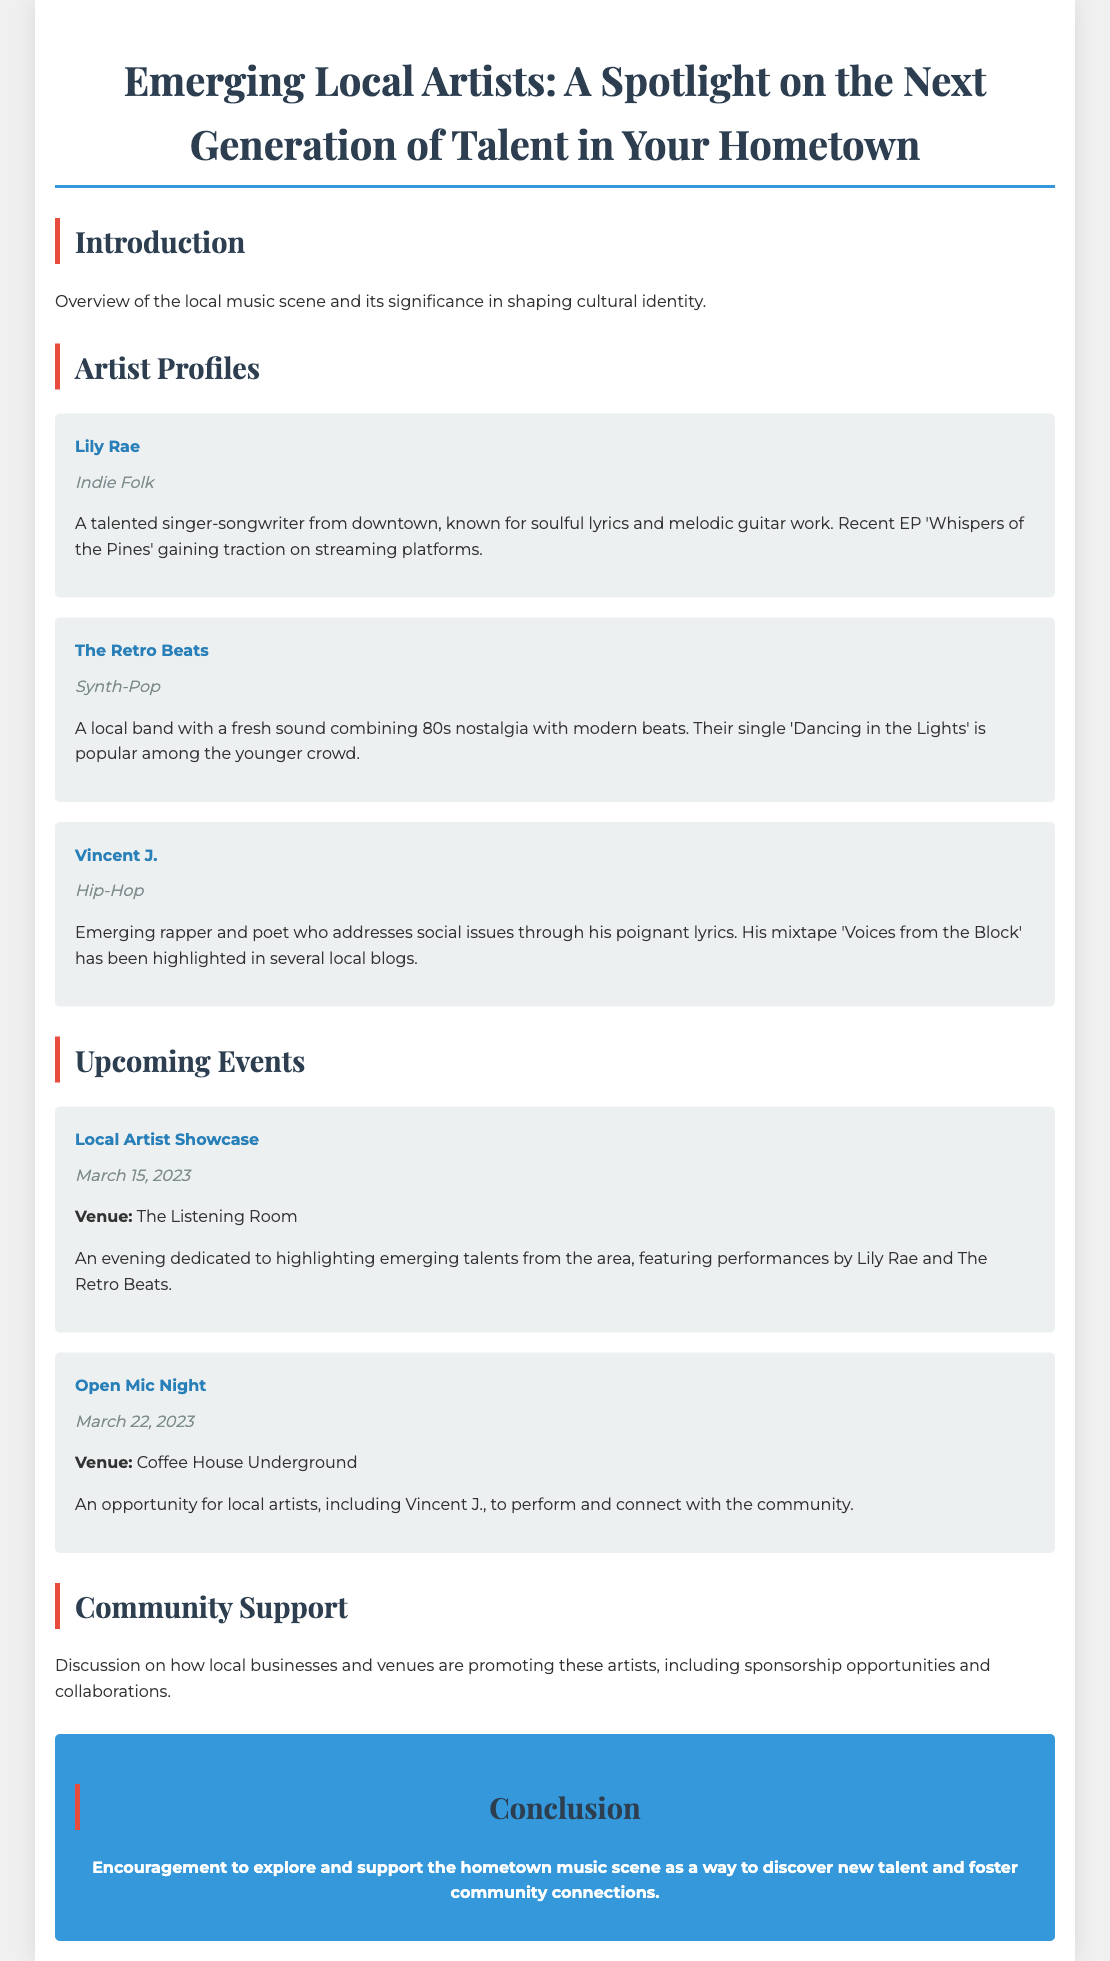What is the title of the document? The title is stated at the beginning of the document and encapsulates the focus on local artists.
Answer: Emerging Local Artists: A Spotlight on the Next Generation of Talent in Your Hometown Who is the first artist profiled? The first artist mentioned in the 'Artist Profiles' section is identified by name.
Answer: Lily Rae What genre does Vincent J. represent? The genre associated with Vincent J. is listed in his profile.
Answer: Hip-Hop When is the Local Artist Showcase event scheduled? The date for the Local Artist Showcase is presented under the 'Upcoming Events' section.
Answer: March 15, 2023 What is the name of the venue for the Open Mic Night? The venue for the Open Mic Night is specifically mentioned in the event details.
Answer: Coffee House Underground What is the focus of the community support section? The section discusses how local businesses engage with artists, indicating its purpose.
Answer: Promotion of local artists Which artist is described as having a popular single among the younger crowd? The document specifically notes which artist has a single appealing to a particular demographic.
Answer: The Retro Beats What is the title of Lily Rae's recent EP? The title is cited as part of her profile, reflecting her recent work.
Answer: Whispers of the Pines What type of music does The Retro Beats play? The genre for The Retro Beats is clearly stated in their profile.
Answer: Synth-Pop 